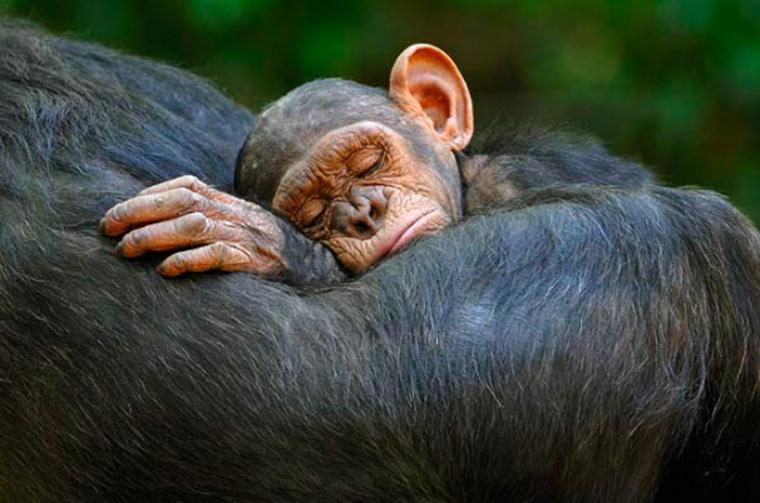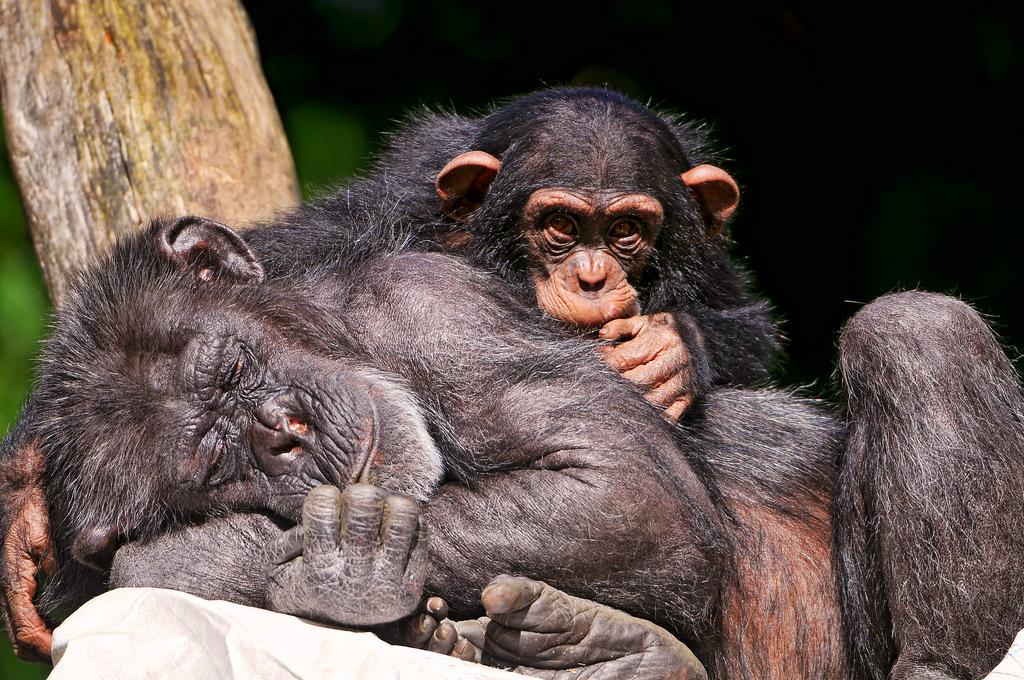The first image is the image on the left, the second image is the image on the right. Examine the images to the left and right. Is the description "There's exactly two chimpanzees." accurate? Answer yes or no. No. 